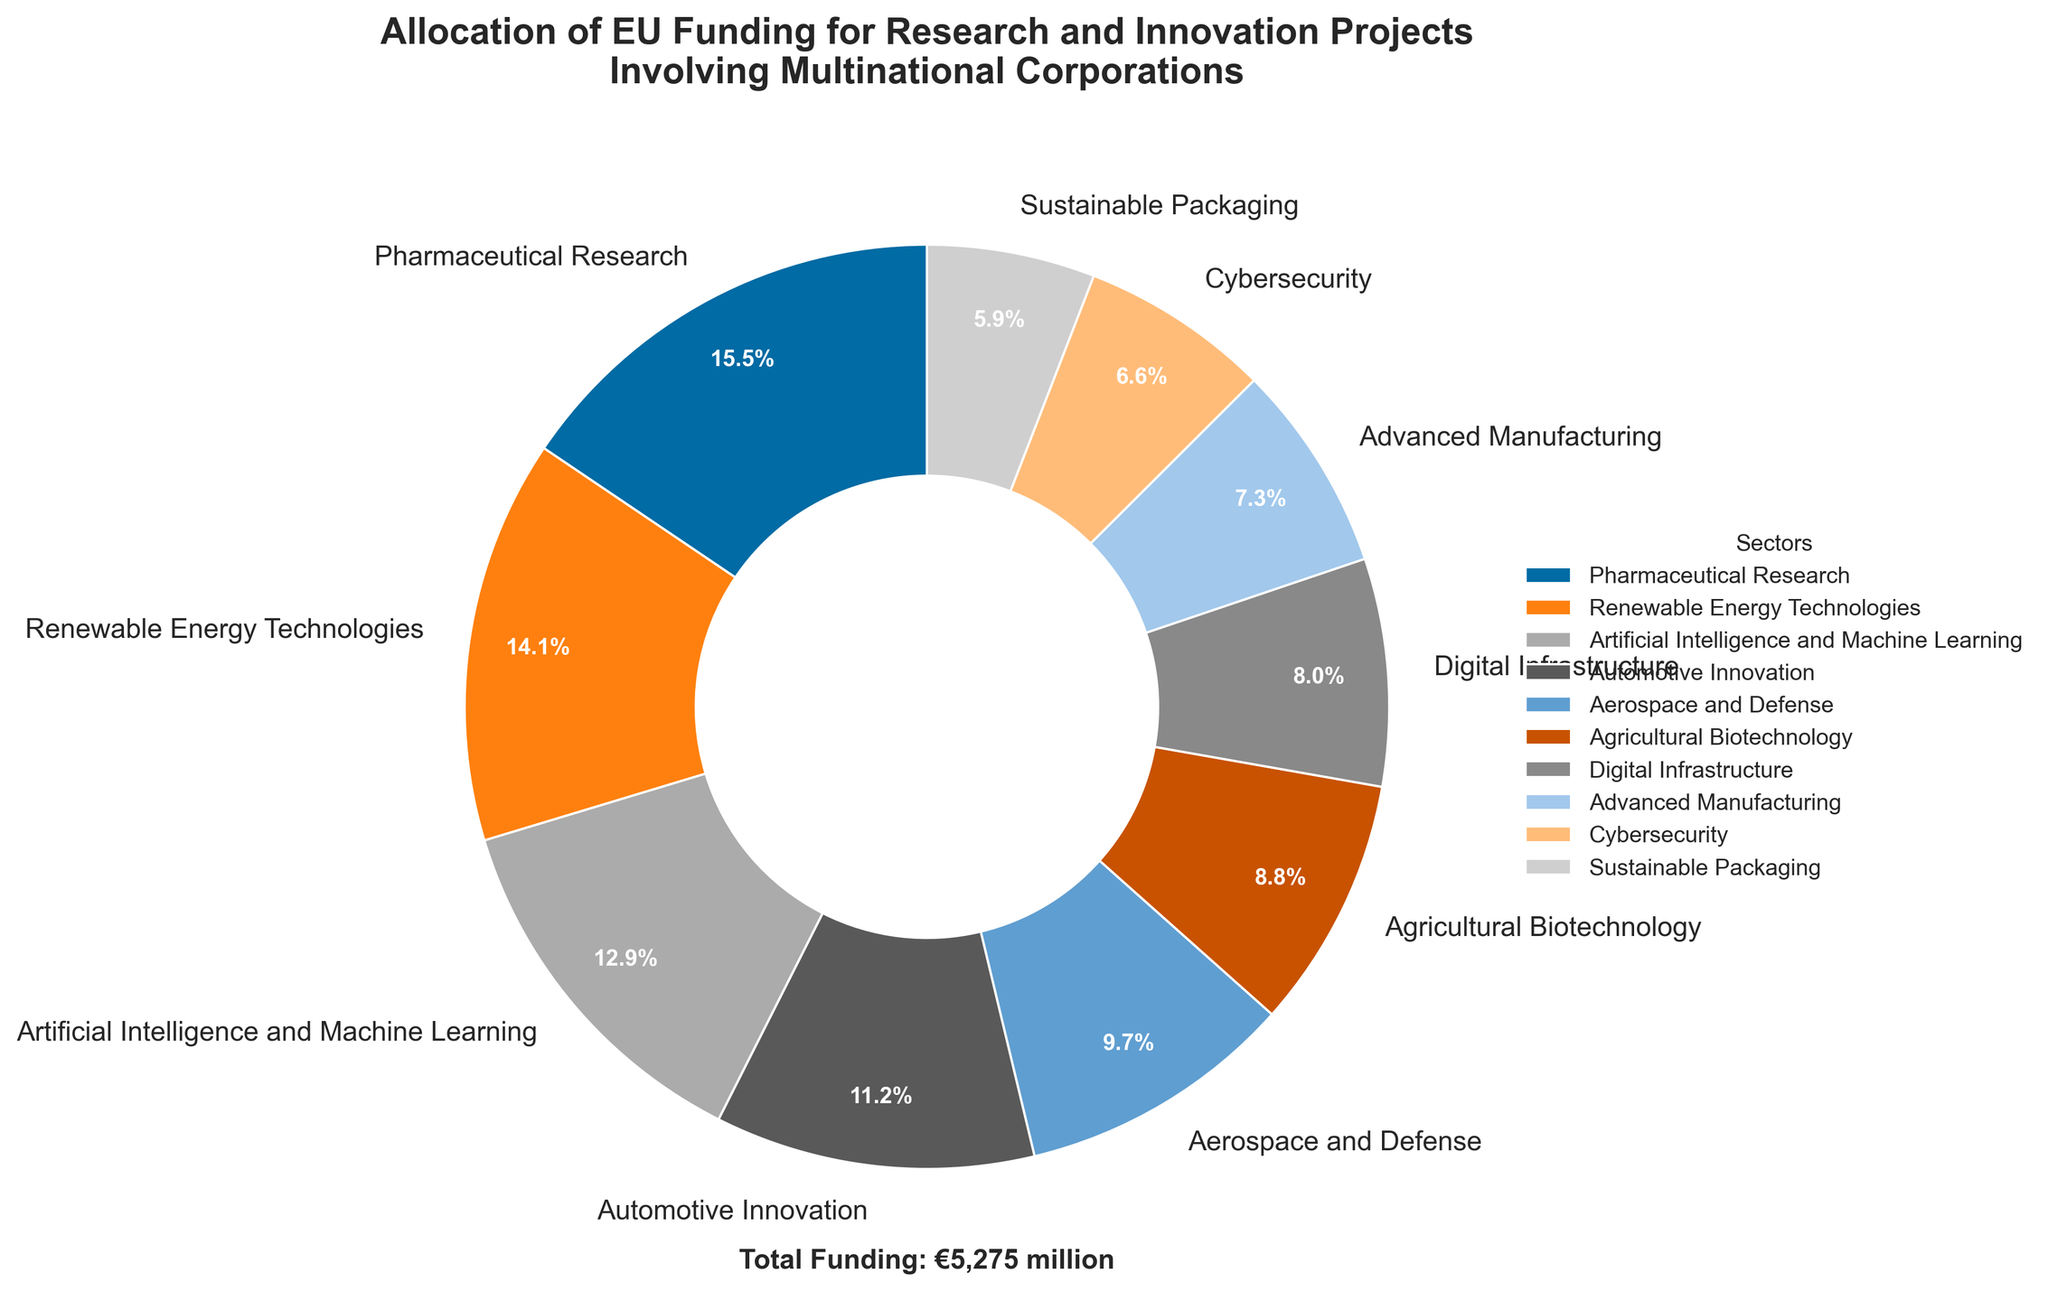what percentage of the total funding is allocated to Pharmaceutical Research? To find the percentage of total funding allocated to Pharmaceutical Research, note the value for Pharmaceutical Research (€820 million) and divide it by the total funding sum (€5,275 million; calculated by summing all the sectors). Then multiply by 100 to convert to percentage: (820/5275)*100 ≈ 15.5%
Answer: 15.5% Is more funding allocated to Artificial Intelligence and Machine Learning or to Automotive Innovation? Compare the funding allocations of Artificial Intelligence and Machine Learning (€680 million) and Automotive Innovation (€590 million). Since 680 > 590, more funding goes to Artificial Intelligence and Machine Learning.
Answer: Artificial Intelligence and Machine Learning How much less funding does Sustainable Packaging receive compared to Aerospace and Defense? Calculate the difference in funding between Sustainable Packaging (€310 million) and Aerospace and Defense (€510 million) by subtracting the smaller value from the larger one: 510 - 310 = 200.
Answer: €200 million What is the combined funding for Digital Infrastructure and Cybersecurity? Add the funding allocations for Digital Infrastructure (€420 million) and Cybersecurity (€350 million) together to find the total: 420 + 350 = 770.
Answer: €770 million Which sector receives approximately 9.8% of the total funding, and how is it visually represented in the chart? Look for the sector that corresponds to 9.8% in the pie chart's labels. Renewable Energy Technologies receives €745 million, which is 745/5275*100 ≈ 14.1%, not 9.8%. Check the next closest: Artificial Intelligence and Machine Learning receives €680 million, which is 680/5275*100 ≈ 12.9%. Finally, Cybersecurity is represented by a slice labeled 6.6%, quite close but not exact. Thus, the closest slice is Renewable Energy Technologies visually represented by the pie chart slice with a notable size labeled 14.1%.
Answer: Renewable Energy Technologies Which two sectors together receive the smallest amount of funding combined, and what is the total? Identify the two smallest individual sectors: Sustainable Packaging (€310 million) and Cybersecurity (€350 million). Add their funding to find the combined total: 310 + 350 = 660.
Answer: Sustainable Packaging and Cybersecurity, €660 million 